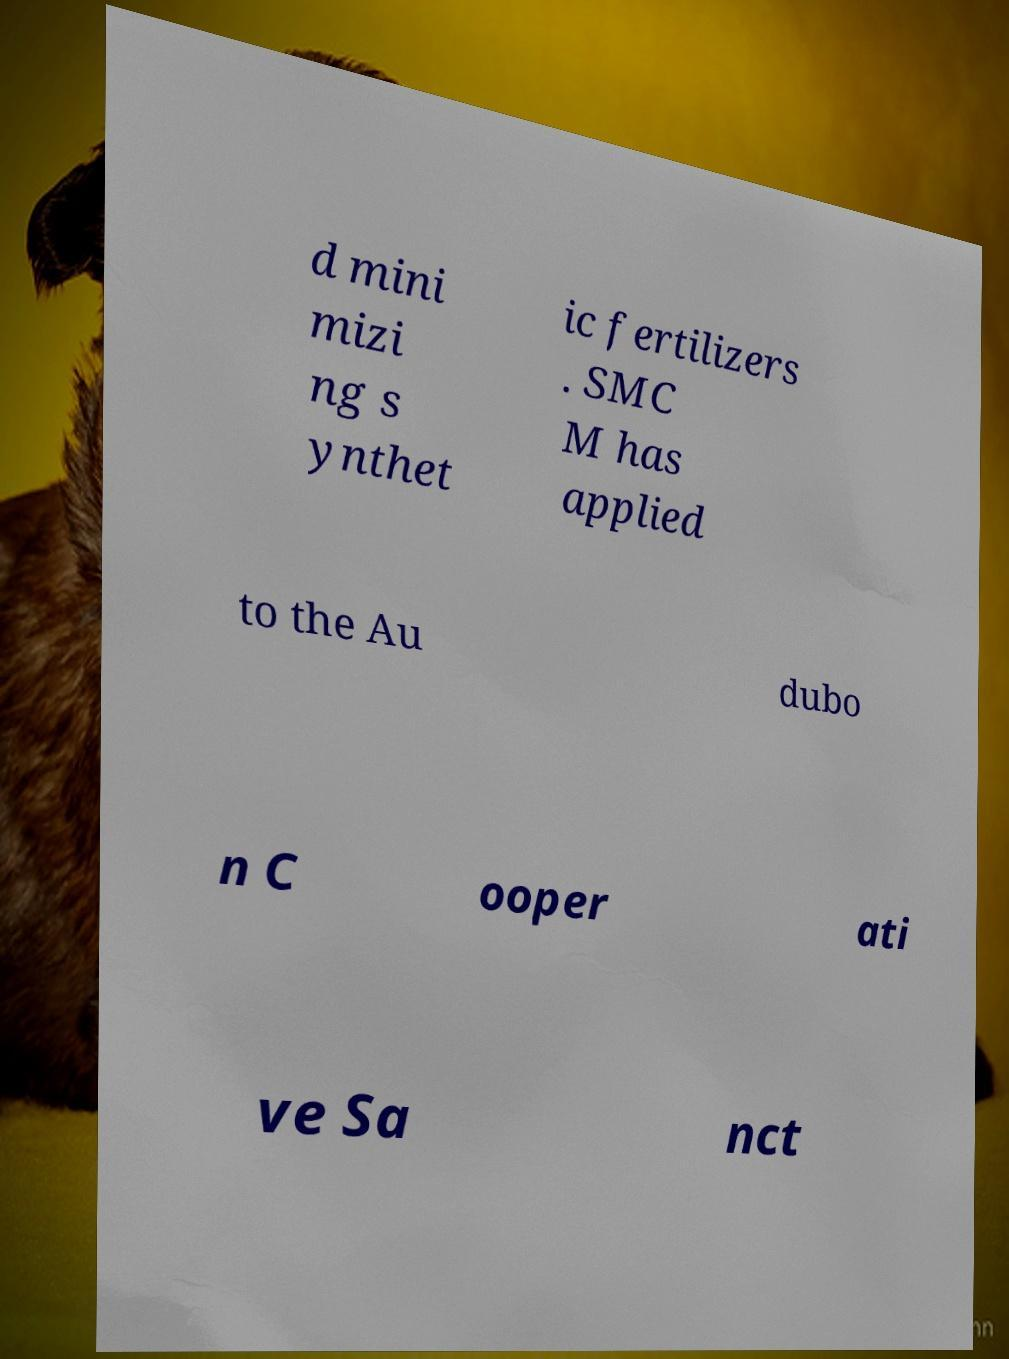Please read and relay the text visible in this image. What does it say? d mini mizi ng s ynthet ic fertilizers . SMC M has applied to the Au dubo n C ooper ati ve Sa nct 